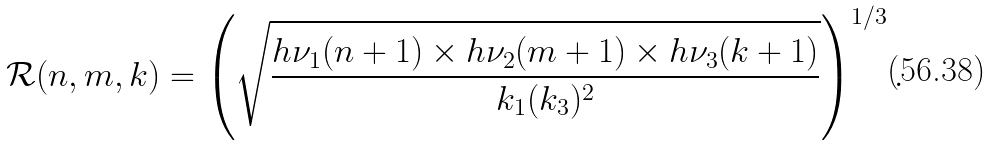<formula> <loc_0><loc_0><loc_500><loc_500>\mathcal { R } ( n , m , k ) = \left ( \sqrt { \frac { h \nu _ { 1 } ( n + 1 ) \times h \nu _ { 2 } ( m + 1 ) \times h \nu _ { 3 } ( k + 1 ) } { k _ { 1 } ( k _ { 3 } ) ^ { 2 } } } \right ) ^ { 1 / 3 } .</formula> 